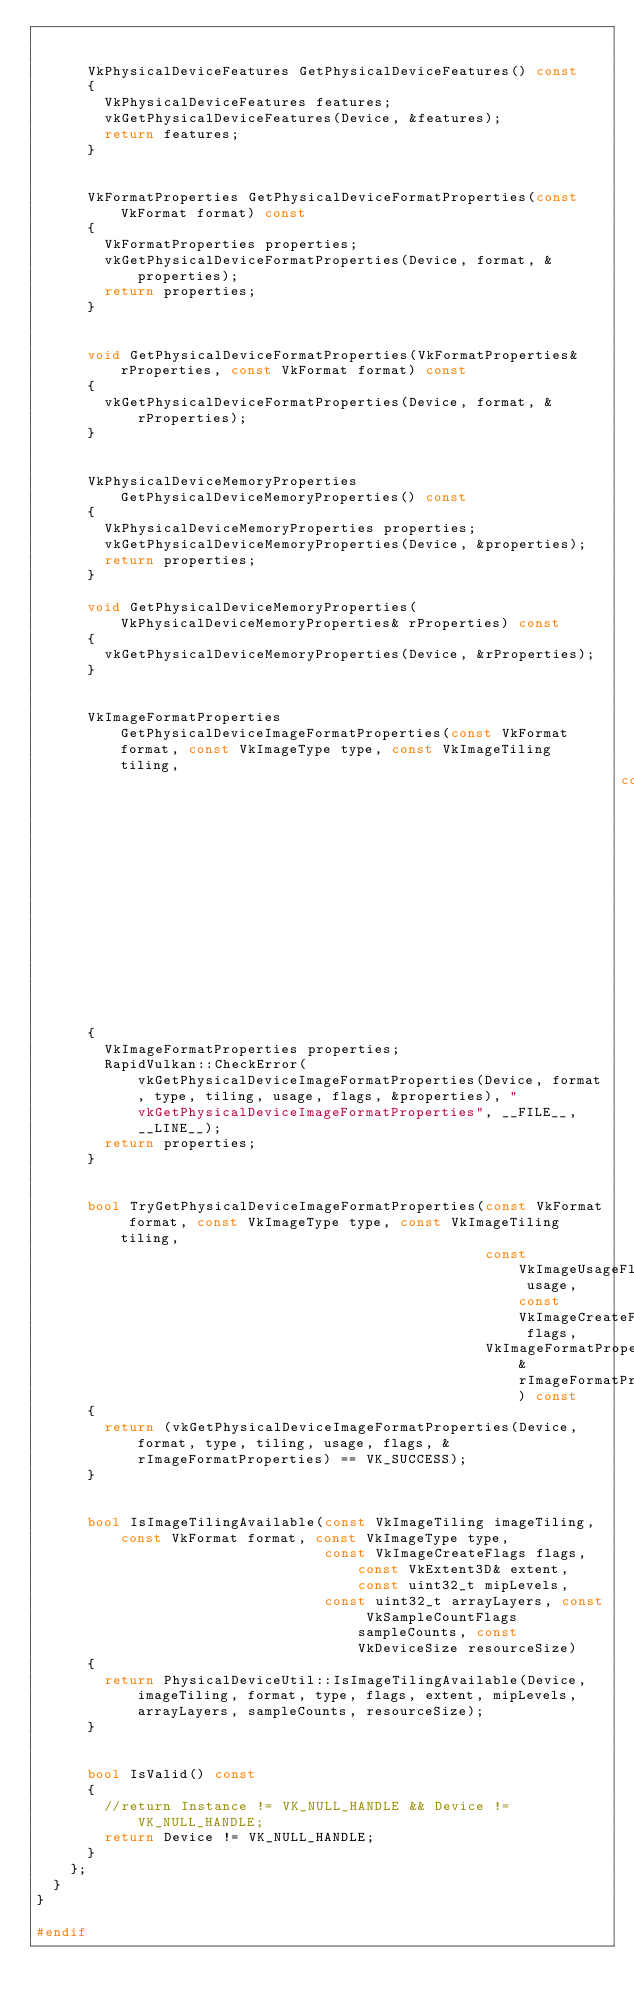Convert code to text. <code><loc_0><loc_0><loc_500><loc_500><_C++_>

      VkPhysicalDeviceFeatures GetPhysicalDeviceFeatures() const
      {
        VkPhysicalDeviceFeatures features;
        vkGetPhysicalDeviceFeatures(Device, &features);
        return features;
      }


      VkFormatProperties GetPhysicalDeviceFormatProperties(const VkFormat format) const
      {
        VkFormatProperties properties;
        vkGetPhysicalDeviceFormatProperties(Device, format, &properties);
        return properties;
      }


      void GetPhysicalDeviceFormatProperties(VkFormatProperties& rProperties, const VkFormat format) const
      {
        vkGetPhysicalDeviceFormatProperties(Device, format, &rProperties);
      }


      VkPhysicalDeviceMemoryProperties GetPhysicalDeviceMemoryProperties() const
      {
        VkPhysicalDeviceMemoryProperties properties;
        vkGetPhysicalDeviceMemoryProperties(Device, &properties);
        return properties;
      }

      void GetPhysicalDeviceMemoryProperties(VkPhysicalDeviceMemoryProperties& rProperties) const
      {
        vkGetPhysicalDeviceMemoryProperties(Device, &rProperties);
      }


      VkImageFormatProperties GetPhysicalDeviceImageFormatProperties(const VkFormat format, const VkImageType type, const VkImageTiling tiling,
                                                                     const VkImageUsageFlags usage, const VkImageCreateFlags flags) const
      {
        VkImageFormatProperties properties;
        RapidVulkan::CheckError(vkGetPhysicalDeviceImageFormatProperties(Device, format, type, tiling, usage, flags, &properties), "vkGetPhysicalDeviceImageFormatProperties", __FILE__, __LINE__);
        return properties;
      }


      bool TryGetPhysicalDeviceImageFormatProperties(const VkFormat format, const VkImageType type, const VkImageTiling tiling,
                                                     const VkImageUsageFlags usage, const VkImageCreateFlags flags,
                                                     VkImageFormatProperties& rImageFormatProperties) const
      {
        return (vkGetPhysicalDeviceImageFormatProperties(Device, format, type, tiling, usage, flags, &rImageFormatProperties) == VK_SUCCESS);
      }


      bool IsImageTilingAvailable(const VkImageTiling imageTiling, const VkFormat format, const VkImageType type,
                                  const VkImageCreateFlags flags, const VkExtent3D& extent, const uint32_t mipLevels,
                                  const uint32_t arrayLayers, const VkSampleCountFlags sampleCounts, const VkDeviceSize resourceSize)
      {
        return PhysicalDeviceUtil::IsImageTilingAvailable(Device, imageTiling, format, type, flags, extent, mipLevels, arrayLayers, sampleCounts, resourceSize);
      }


      bool IsValid() const
      {
        //return Instance != VK_NULL_HANDLE && Device != VK_NULL_HANDLE;
        return Device != VK_NULL_HANDLE;
      }
    };
  }
}

#endif
</code> 